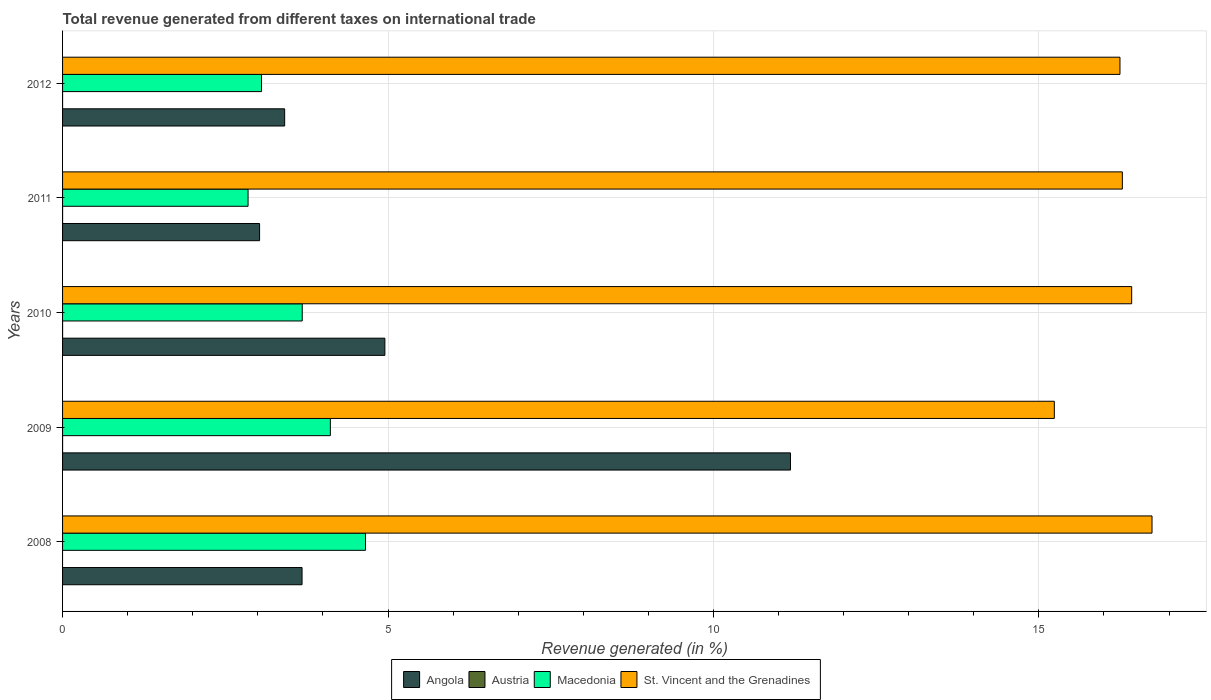How many different coloured bars are there?
Provide a succinct answer. 4. Are the number of bars per tick equal to the number of legend labels?
Keep it short and to the point. No. How many bars are there on the 3rd tick from the bottom?
Offer a terse response. 4. In how many cases, is the number of bars for a given year not equal to the number of legend labels?
Your answer should be compact. 1. What is the total revenue generated in Macedonia in 2012?
Keep it short and to the point. 3.06. Across all years, what is the maximum total revenue generated in Macedonia?
Offer a terse response. 4.65. Across all years, what is the minimum total revenue generated in Angola?
Your answer should be very brief. 3.03. What is the total total revenue generated in Angola in the graph?
Offer a terse response. 26.25. What is the difference between the total revenue generated in St. Vincent and the Grenadines in 2009 and that in 2010?
Your answer should be very brief. -1.19. What is the difference between the total revenue generated in Macedonia in 2010 and the total revenue generated in St. Vincent and the Grenadines in 2008?
Offer a very short reply. -13.06. What is the average total revenue generated in Macedonia per year?
Provide a succinct answer. 3.67. In the year 2010, what is the difference between the total revenue generated in Austria and total revenue generated in Angola?
Give a very brief answer. -4.95. In how many years, is the total revenue generated in Macedonia greater than 7 %?
Your answer should be compact. 0. What is the ratio of the total revenue generated in Macedonia in 2010 to that in 2011?
Offer a terse response. 1.29. Is the difference between the total revenue generated in Austria in 2009 and 2012 greater than the difference between the total revenue generated in Angola in 2009 and 2012?
Your answer should be very brief. No. What is the difference between the highest and the second highest total revenue generated in Macedonia?
Your answer should be compact. 0.54. What is the difference between the highest and the lowest total revenue generated in Angola?
Give a very brief answer. 8.16. In how many years, is the total revenue generated in Austria greater than the average total revenue generated in Austria taken over all years?
Offer a terse response. 4. Is the sum of the total revenue generated in St. Vincent and the Grenadines in 2010 and 2012 greater than the maximum total revenue generated in Angola across all years?
Keep it short and to the point. Yes. Are all the bars in the graph horizontal?
Provide a short and direct response. Yes. How many years are there in the graph?
Keep it short and to the point. 5. Does the graph contain grids?
Make the answer very short. Yes. What is the title of the graph?
Offer a very short reply. Total revenue generated from different taxes on international trade. Does "Lithuania" appear as one of the legend labels in the graph?
Keep it short and to the point. No. What is the label or title of the X-axis?
Ensure brevity in your answer.  Revenue generated (in %). What is the label or title of the Y-axis?
Keep it short and to the point. Years. What is the Revenue generated (in %) of Angola in 2008?
Provide a short and direct response. 3.68. What is the Revenue generated (in %) in Austria in 2008?
Offer a terse response. 0. What is the Revenue generated (in %) in Macedonia in 2008?
Provide a short and direct response. 4.65. What is the Revenue generated (in %) in St. Vincent and the Grenadines in 2008?
Offer a terse response. 16.74. What is the Revenue generated (in %) in Angola in 2009?
Ensure brevity in your answer.  11.18. What is the Revenue generated (in %) in Austria in 2009?
Your answer should be very brief. 6.92844166875675e-5. What is the Revenue generated (in %) of Macedonia in 2009?
Ensure brevity in your answer.  4.11. What is the Revenue generated (in %) in St. Vincent and the Grenadines in 2009?
Offer a very short reply. 15.24. What is the Revenue generated (in %) in Angola in 2010?
Provide a short and direct response. 4.95. What is the Revenue generated (in %) in Austria in 2010?
Give a very brief answer. 8.59505597100448e-5. What is the Revenue generated (in %) in Macedonia in 2010?
Offer a terse response. 3.68. What is the Revenue generated (in %) in St. Vincent and the Grenadines in 2010?
Offer a terse response. 16.43. What is the Revenue generated (in %) in Angola in 2011?
Keep it short and to the point. 3.03. What is the Revenue generated (in %) in Austria in 2011?
Keep it short and to the point. 7.3236472605577e-5. What is the Revenue generated (in %) of Macedonia in 2011?
Provide a short and direct response. 2.85. What is the Revenue generated (in %) of St. Vincent and the Grenadines in 2011?
Your response must be concise. 16.28. What is the Revenue generated (in %) of Angola in 2012?
Offer a terse response. 3.41. What is the Revenue generated (in %) of Austria in 2012?
Offer a terse response. 6.14359728333639e-5. What is the Revenue generated (in %) in Macedonia in 2012?
Provide a short and direct response. 3.06. What is the Revenue generated (in %) in St. Vincent and the Grenadines in 2012?
Offer a terse response. 16.25. Across all years, what is the maximum Revenue generated (in %) of Angola?
Offer a terse response. 11.18. Across all years, what is the maximum Revenue generated (in %) in Austria?
Your answer should be very brief. 8.59505597100448e-5. Across all years, what is the maximum Revenue generated (in %) of Macedonia?
Your answer should be very brief. 4.65. Across all years, what is the maximum Revenue generated (in %) of St. Vincent and the Grenadines?
Provide a short and direct response. 16.74. Across all years, what is the minimum Revenue generated (in %) of Angola?
Make the answer very short. 3.03. Across all years, what is the minimum Revenue generated (in %) in Macedonia?
Your response must be concise. 2.85. Across all years, what is the minimum Revenue generated (in %) in St. Vincent and the Grenadines?
Make the answer very short. 15.24. What is the total Revenue generated (in %) of Angola in the graph?
Keep it short and to the point. 26.25. What is the total Revenue generated (in %) of Macedonia in the graph?
Provide a short and direct response. 18.36. What is the total Revenue generated (in %) in St. Vincent and the Grenadines in the graph?
Your answer should be very brief. 80.93. What is the difference between the Revenue generated (in %) of Angola in 2008 and that in 2009?
Provide a succinct answer. -7.5. What is the difference between the Revenue generated (in %) of Macedonia in 2008 and that in 2009?
Keep it short and to the point. 0.54. What is the difference between the Revenue generated (in %) in St. Vincent and the Grenadines in 2008 and that in 2009?
Give a very brief answer. 1.5. What is the difference between the Revenue generated (in %) in Angola in 2008 and that in 2010?
Your answer should be very brief. -1.27. What is the difference between the Revenue generated (in %) of Macedonia in 2008 and that in 2010?
Offer a very short reply. 0.97. What is the difference between the Revenue generated (in %) of St. Vincent and the Grenadines in 2008 and that in 2010?
Your response must be concise. 0.31. What is the difference between the Revenue generated (in %) of Angola in 2008 and that in 2011?
Your answer should be compact. 0.65. What is the difference between the Revenue generated (in %) in Macedonia in 2008 and that in 2011?
Provide a succinct answer. 1.8. What is the difference between the Revenue generated (in %) in St. Vincent and the Grenadines in 2008 and that in 2011?
Offer a terse response. 0.46. What is the difference between the Revenue generated (in %) in Angola in 2008 and that in 2012?
Make the answer very short. 0.27. What is the difference between the Revenue generated (in %) of Macedonia in 2008 and that in 2012?
Ensure brevity in your answer.  1.6. What is the difference between the Revenue generated (in %) in St. Vincent and the Grenadines in 2008 and that in 2012?
Make the answer very short. 0.49. What is the difference between the Revenue generated (in %) of Angola in 2009 and that in 2010?
Give a very brief answer. 6.23. What is the difference between the Revenue generated (in %) in Austria in 2009 and that in 2010?
Give a very brief answer. -0. What is the difference between the Revenue generated (in %) in Macedonia in 2009 and that in 2010?
Offer a very short reply. 0.43. What is the difference between the Revenue generated (in %) in St. Vincent and the Grenadines in 2009 and that in 2010?
Your answer should be compact. -1.19. What is the difference between the Revenue generated (in %) of Angola in 2009 and that in 2011?
Give a very brief answer. 8.16. What is the difference between the Revenue generated (in %) of Austria in 2009 and that in 2011?
Keep it short and to the point. -0. What is the difference between the Revenue generated (in %) in Macedonia in 2009 and that in 2011?
Provide a short and direct response. 1.26. What is the difference between the Revenue generated (in %) in St. Vincent and the Grenadines in 2009 and that in 2011?
Your answer should be compact. -1.04. What is the difference between the Revenue generated (in %) of Angola in 2009 and that in 2012?
Keep it short and to the point. 7.77. What is the difference between the Revenue generated (in %) of Macedonia in 2009 and that in 2012?
Ensure brevity in your answer.  1.06. What is the difference between the Revenue generated (in %) of St. Vincent and the Grenadines in 2009 and that in 2012?
Provide a succinct answer. -1.01. What is the difference between the Revenue generated (in %) in Angola in 2010 and that in 2011?
Provide a succinct answer. 1.93. What is the difference between the Revenue generated (in %) in Macedonia in 2010 and that in 2011?
Your answer should be compact. 0.83. What is the difference between the Revenue generated (in %) in St. Vincent and the Grenadines in 2010 and that in 2011?
Offer a very short reply. 0.14. What is the difference between the Revenue generated (in %) in Angola in 2010 and that in 2012?
Your response must be concise. 1.54. What is the difference between the Revenue generated (in %) of Macedonia in 2010 and that in 2012?
Your answer should be very brief. 0.63. What is the difference between the Revenue generated (in %) of St. Vincent and the Grenadines in 2010 and that in 2012?
Offer a very short reply. 0.18. What is the difference between the Revenue generated (in %) of Angola in 2011 and that in 2012?
Make the answer very short. -0.39. What is the difference between the Revenue generated (in %) in Austria in 2011 and that in 2012?
Your answer should be compact. 0. What is the difference between the Revenue generated (in %) in Macedonia in 2011 and that in 2012?
Provide a short and direct response. -0.21. What is the difference between the Revenue generated (in %) in St. Vincent and the Grenadines in 2011 and that in 2012?
Provide a short and direct response. 0.04. What is the difference between the Revenue generated (in %) in Angola in 2008 and the Revenue generated (in %) in Austria in 2009?
Your answer should be very brief. 3.68. What is the difference between the Revenue generated (in %) in Angola in 2008 and the Revenue generated (in %) in Macedonia in 2009?
Your response must be concise. -0.43. What is the difference between the Revenue generated (in %) of Angola in 2008 and the Revenue generated (in %) of St. Vincent and the Grenadines in 2009?
Keep it short and to the point. -11.56. What is the difference between the Revenue generated (in %) in Macedonia in 2008 and the Revenue generated (in %) in St. Vincent and the Grenadines in 2009?
Your answer should be very brief. -10.58. What is the difference between the Revenue generated (in %) in Angola in 2008 and the Revenue generated (in %) in Austria in 2010?
Your answer should be very brief. 3.68. What is the difference between the Revenue generated (in %) in Angola in 2008 and the Revenue generated (in %) in Macedonia in 2010?
Keep it short and to the point. -0. What is the difference between the Revenue generated (in %) in Angola in 2008 and the Revenue generated (in %) in St. Vincent and the Grenadines in 2010?
Offer a very short reply. -12.75. What is the difference between the Revenue generated (in %) of Macedonia in 2008 and the Revenue generated (in %) of St. Vincent and the Grenadines in 2010?
Give a very brief answer. -11.77. What is the difference between the Revenue generated (in %) in Angola in 2008 and the Revenue generated (in %) in Austria in 2011?
Ensure brevity in your answer.  3.68. What is the difference between the Revenue generated (in %) of Angola in 2008 and the Revenue generated (in %) of Macedonia in 2011?
Give a very brief answer. 0.83. What is the difference between the Revenue generated (in %) of Angola in 2008 and the Revenue generated (in %) of St. Vincent and the Grenadines in 2011?
Offer a terse response. -12.6. What is the difference between the Revenue generated (in %) of Macedonia in 2008 and the Revenue generated (in %) of St. Vincent and the Grenadines in 2011?
Ensure brevity in your answer.  -11.63. What is the difference between the Revenue generated (in %) of Angola in 2008 and the Revenue generated (in %) of Austria in 2012?
Offer a terse response. 3.68. What is the difference between the Revenue generated (in %) of Angola in 2008 and the Revenue generated (in %) of Macedonia in 2012?
Your answer should be compact. 0.62. What is the difference between the Revenue generated (in %) in Angola in 2008 and the Revenue generated (in %) in St. Vincent and the Grenadines in 2012?
Give a very brief answer. -12.57. What is the difference between the Revenue generated (in %) in Macedonia in 2008 and the Revenue generated (in %) in St. Vincent and the Grenadines in 2012?
Provide a short and direct response. -11.59. What is the difference between the Revenue generated (in %) in Angola in 2009 and the Revenue generated (in %) in Austria in 2010?
Make the answer very short. 11.18. What is the difference between the Revenue generated (in %) of Angola in 2009 and the Revenue generated (in %) of Macedonia in 2010?
Your answer should be very brief. 7.5. What is the difference between the Revenue generated (in %) in Angola in 2009 and the Revenue generated (in %) in St. Vincent and the Grenadines in 2010?
Your answer should be very brief. -5.24. What is the difference between the Revenue generated (in %) of Austria in 2009 and the Revenue generated (in %) of Macedonia in 2010?
Keep it short and to the point. -3.68. What is the difference between the Revenue generated (in %) of Austria in 2009 and the Revenue generated (in %) of St. Vincent and the Grenadines in 2010?
Your answer should be compact. -16.43. What is the difference between the Revenue generated (in %) in Macedonia in 2009 and the Revenue generated (in %) in St. Vincent and the Grenadines in 2010?
Keep it short and to the point. -12.31. What is the difference between the Revenue generated (in %) of Angola in 2009 and the Revenue generated (in %) of Austria in 2011?
Offer a terse response. 11.18. What is the difference between the Revenue generated (in %) of Angola in 2009 and the Revenue generated (in %) of Macedonia in 2011?
Your answer should be compact. 8.33. What is the difference between the Revenue generated (in %) of Angola in 2009 and the Revenue generated (in %) of St. Vincent and the Grenadines in 2011?
Your answer should be very brief. -5.1. What is the difference between the Revenue generated (in %) in Austria in 2009 and the Revenue generated (in %) in Macedonia in 2011?
Keep it short and to the point. -2.85. What is the difference between the Revenue generated (in %) of Austria in 2009 and the Revenue generated (in %) of St. Vincent and the Grenadines in 2011?
Provide a short and direct response. -16.28. What is the difference between the Revenue generated (in %) of Macedonia in 2009 and the Revenue generated (in %) of St. Vincent and the Grenadines in 2011?
Make the answer very short. -12.17. What is the difference between the Revenue generated (in %) of Angola in 2009 and the Revenue generated (in %) of Austria in 2012?
Your response must be concise. 11.18. What is the difference between the Revenue generated (in %) of Angola in 2009 and the Revenue generated (in %) of Macedonia in 2012?
Make the answer very short. 8.13. What is the difference between the Revenue generated (in %) in Angola in 2009 and the Revenue generated (in %) in St. Vincent and the Grenadines in 2012?
Offer a very short reply. -5.06. What is the difference between the Revenue generated (in %) in Austria in 2009 and the Revenue generated (in %) in Macedonia in 2012?
Keep it short and to the point. -3.06. What is the difference between the Revenue generated (in %) in Austria in 2009 and the Revenue generated (in %) in St. Vincent and the Grenadines in 2012?
Give a very brief answer. -16.25. What is the difference between the Revenue generated (in %) in Macedonia in 2009 and the Revenue generated (in %) in St. Vincent and the Grenadines in 2012?
Your answer should be very brief. -12.13. What is the difference between the Revenue generated (in %) of Angola in 2010 and the Revenue generated (in %) of Austria in 2011?
Ensure brevity in your answer.  4.95. What is the difference between the Revenue generated (in %) of Angola in 2010 and the Revenue generated (in %) of Macedonia in 2011?
Provide a succinct answer. 2.1. What is the difference between the Revenue generated (in %) of Angola in 2010 and the Revenue generated (in %) of St. Vincent and the Grenadines in 2011?
Give a very brief answer. -11.33. What is the difference between the Revenue generated (in %) of Austria in 2010 and the Revenue generated (in %) of Macedonia in 2011?
Your answer should be compact. -2.85. What is the difference between the Revenue generated (in %) in Austria in 2010 and the Revenue generated (in %) in St. Vincent and the Grenadines in 2011?
Give a very brief answer. -16.28. What is the difference between the Revenue generated (in %) in Macedonia in 2010 and the Revenue generated (in %) in St. Vincent and the Grenadines in 2011?
Make the answer very short. -12.6. What is the difference between the Revenue generated (in %) in Angola in 2010 and the Revenue generated (in %) in Austria in 2012?
Keep it short and to the point. 4.95. What is the difference between the Revenue generated (in %) of Angola in 2010 and the Revenue generated (in %) of Macedonia in 2012?
Give a very brief answer. 1.9. What is the difference between the Revenue generated (in %) in Angola in 2010 and the Revenue generated (in %) in St. Vincent and the Grenadines in 2012?
Provide a succinct answer. -11.29. What is the difference between the Revenue generated (in %) in Austria in 2010 and the Revenue generated (in %) in Macedonia in 2012?
Offer a terse response. -3.06. What is the difference between the Revenue generated (in %) of Austria in 2010 and the Revenue generated (in %) of St. Vincent and the Grenadines in 2012?
Offer a terse response. -16.25. What is the difference between the Revenue generated (in %) in Macedonia in 2010 and the Revenue generated (in %) in St. Vincent and the Grenadines in 2012?
Make the answer very short. -12.56. What is the difference between the Revenue generated (in %) in Angola in 2011 and the Revenue generated (in %) in Austria in 2012?
Provide a succinct answer. 3.03. What is the difference between the Revenue generated (in %) of Angola in 2011 and the Revenue generated (in %) of Macedonia in 2012?
Make the answer very short. -0.03. What is the difference between the Revenue generated (in %) in Angola in 2011 and the Revenue generated (in %) in St. Vincent and the Grenadines in 2012?
Provide a short and direct response. -13.22. What is the difference between the Revenue generated (in %) in Austria in 2011 and the Revenue generated (in %) in Macedonia in 2012?
Your answer should be compact. -3.06. What is the difference between the Revenue generated (in %) of Austria in 2011 and the Revenue generated (in %) of St. Vincent and the Grenadines in 2012?
Your answer should be compact. -16.25. What is the difference between the Revenue generated (in %) in Macedonia in 2011 and the Revenue generated (in %) in St. Vincent and the Grenadines in 2012?
Offer a terse response. -13.4. What is the average Revenue generated (in %) of Angola per year?
Give a very brief answer. 5.25. What is the average Revenue generated (in %) in Macedonia per year?
Keep it short and to the point. 3.67. What is the average Revenue generated (in %) of St. Vincent and the Grenadines per year?
Provide a short and direct response. 16.19. In the year 2008, what is the difference between the Revenue generated (in %) of Angola and Revenue generated (in %) of Macedonia?
Your response must be concise. -0.97. In the year 2008, what is the difference between the Revenue generated (in %) of Angola and Revenue generated (in %) of St. Vincent and the Grenadines?
Make the answer very short. -13.06. In the year 2008, what is the difference between the Revenue generated (in %) in Macedonia and Revenue generated (in %) in St. Vincent and the Grenadines?
Your answer should be compact. -12.08. In the year 2009, what is the difference between the Revenue generated (in %) in Angola and Revenue generated (in %) in Austria?
Give a very brief answer. 11.18. In the year 2009, what is the difference between the Revenue generated (in %) in Angola and Revenue generated (in %) in Macedonia?
Keep it short and to the point. 7.07. In the year 2009, what is the difference between the Revenue generated (in %) of Angola and Revenue generated (in %) of St. Vincent and the Grenadines?
Give a very brief answer. -4.05. In the year 2009, what is the difference between the Revenue generated (in %) of Austria and Revenue generated (in %) of Macedonia?
Your answer should be compact. -4.11. In the year 2009, what is the difference between the Revenue generated (in %) in Austria and Revenue generated (in %) in St. Vincent and the Grenadines?
Make the answer very short. -15.24. In the year 2009, what is the difference between the Revenue generated (in %) in Macedonia and Revenue generated (in %) in St. Vincent and the Grenadines?
Provide a short and direct response. -11.12. In the year 2010, what is the difference between the Revenue generated (in %) of Angola and Revenue generated (in %) of Austria?
Keep it short and to the point. 4.95. In the year 2010, what is the difference between the Revenue generated (in %) in Angola and Revenue generated (in %) in Macedonia?
Your response must be concise. 1.27. In the year 2010, what is the difference between the Revenue generated (in %) in Angola and Revenue generated (in %) in St. Vincent and the Grenadines?
Provide a succinct answer. -11.47. In the year 2010, what is the difference between the Revenue generated (in %) of Austria and Revenue generated (in %) of Macedonia?
Provide a short and direct response. -3.68. In the year 2010, what is the difference between the Revenue generated (in %) of Austria and Revenue generated (in %) of St. Vincent and the Grenadines?
Your response must be concise. -16.43. In the year 2010, what is the difference between the Revenue generated (in %) of Macedonia and Revenue generated (in %) of St. Vincent and the Grenadines?
Provide a short and direct response. -12.74. In the year 2011, what is the difference between the Revenue generated (in %) of Angola and Revenue generated (in %) of Austria?
Make the answer very short. 3.03. In the year 2011, what is the difference between the Revenue generated (in %) of Angola and Revenue generated (in %) of Macedonia?
Your answer should be very brief. 0.18. In the year 2011, what is the difference between the Revenue generated (in %) of Angola and Revenue generated (in %) of St. Vincent and the Grenadines?
Ensure brevity in your answer.  -13.26. In the year 2011, what is the difference between the Revenue generated (in %) of Austria and Revenue generated (in %) of Macedonia?
Your answer should be compact. -2.85. In the year 2011, what is the difference between the Revenue generated (in %) of Austria and Revenue generated (in %) of St. Vincent and the Grenadines?
Provide a short and direct response. -16.28. In the year 2011, what is the difference between the Revenue generated (in %) in Macedonia and Revenue generated (in %) in St. Vincent and the Grenadines?
Ensure brevity in your answer.  -13.43. In the year 2012, what is the difference between the Revenue generated (in %) in Angola and Revenue generated (in %) in Austria?
Provide a short and direct response. 3.41. In the year 2012, what is the difference between the Revenue generated (in %) of Angola and Revenue generated (in %) of Macedonia?
Make the answer very short. 0.36. In the year 2012, what is the difference between the Revenue generated (in %) in Angola and Revenue generated (in %) in St. Vincent and the Grenadines?
Your answer should be very brief. -12.83. In the year 2012, what is the difference between the Revenue generated (in %) of Austria and Revenue generated (in %) of Macedonia?
Provide a succinct answer. -3.06. In the year 2012, what is the difference between the Revenue generated (in %) of Austria and Revenue generated (in %) of St. Vincent and the Grenadines?
Your response must be concise. -16.25. In the year 2012, what is the difference between the Revenue generated (in %) of Macedonia and Revenue generated (in %) of St. Vincent and the Grenadines?
Your answer should be compact. -13.19. What is the ratio of the Revenue generated (in %) of Angola in 2008 to that in 2009?
Offer a terse response. 0.33. What is the ratio of the Revenue generated (in %) in Macedonia in 2008 to that in 2009?
Make the answer very short. 1.13. What is the ratio of the Revenue generated (in %) of St. Vincent and the Grenadines in 2008 to that in 2009?
Your answer should be very brief. 1.1. What is the ratio of the Revenue generated (in %) of Angola in 2008 to that in 2010?
Offer a very short reply. 0.74. What is the ratio of the Revenue generated (in %) of Macedonia in 2008 to that in 2010?
Make the answer very short. 1.26. What is the ratio of the Revenue generated (in %) of Angola in 2008 to that in 2011?
Offer a terse response. 1.22. What is the ratio of the Revenue generated (in %) in Macedonia in 2008 to that in 2011?
Keep it short and to the point. 1.63. What is the ratio of the Revenue generated (in %) in St. Vincent and the Grenadines in 2008 to that in 2011?
Ensure brevity in your answer.  1.03. What is the ratio of the Revenue generated (in %) in Angola in 2008 to that in 2012?
Offer a terse response. 1.08. What is the ratio of the Revenue generated (in %) in Macedonia in 2008 to that in 2012?
Your answer should be very brief. 1.52. What is the ratio of the Revenue generated (in %) of St. Vincent and the Grenadines in 2008 to that in 2012?
Make the answer very short. 1.03. What is the ratio of the Revenue generated (in %) of Angola in 2009 to that in 2010?
Offer a terse response. 2.26. What is the ratio of the Revenue generated (in %) of Austria in 2009 to that in 2010?
Provide a short and direct response. 0.81. What is the ratio of the Revenue generated (in %) of Macedonia in 2009 to that in 2010?
Offer a very short reply. 1.12. What is the ratio of the Revenue generated (in %) of St. Vincent and the Grenadines in 2009 to that in 2010?
Keep it short and to the point. 0.93. What is the ratio of the Revenue generated (in %) of Angola in 2009 to that in 2011?
Ensure brevity in your answer.  3.69. What is the ratio of the Revenue generated (in %) of Austria in 2009 to that in 2011?
Offer a terse response. 0.95. What is the ratio of the Revenue generated (in %) in Macedonia in 2009 to that in 2011?
Your response must be concise. 1.44. What is the ratio of the Revenue generated (in %) of St. Vincent and the Grenadines in 2009 to that in 2011?
Make the answer very short. 0.94. What is the ratio of the Revenue generated (in %) in Angola in 2009 to that in 2012?
Ensure brevity in your answer.  3.28. What is the ratio of the Revenue generated (in %) in Austria in 2009 to that in 2012?
Offer a terse response. 1.13. What is the ratio of the Revenue generated (in %) in Macedonia in 2009 to that in 2012?
Keep it short and to the point. 1.35. What is the ratio of the Revenue generated (in %) of St. Vincent and the Grenadines in 2009 to that in 2012?
Make the answer very short. 0.94. What is the ratio of the Revenue generated (in %) in Angola in 2010 to that in 2011?
Your response must be concise. 1.64. What is the ratio of the Revenue generated (in %) of Austria in 2010 to that in 2011?
Provide a short and direct response. 1.17. What is the ratio of the Revenue generated (in %) in Macedonia in 2010 to that in 2011?
Offer a terse response. 1.29. What is the ratio of the Revenue generated (in %) of St. Vincent and the Grenadines in 2010 to that in 2011?
Ensure brevity in your answer.  1.01. What is the ratio of the Revenue generated (in %) in Angola in 2010 to that in 2012?
Your response must be concise. 1.45. What is the ratio of the Revenue generated (in %) of Austria in 2010 to that in 2012?
Provide a short and direct response. 1.4. What is the ratio of the Revenue generated (in %) in Macedonia in 2010 to that in 2012?
Your response must be concise. 1.2. What is the ratio of the Revenue generated (in %) in St. Vincent and the Grenadines in 2010 to that in 2012?
Keep it short and to the point. 1.01. What is the ratio of the Revenue generated (in %) of Angola in 2011 to that in 2012?
Your response must be concise. 0.89. What is the ratio of the Revenue generated (in %) in Austria in 2011 to that in 2012?
Your response must be concise. 1.19. What is the ratio of the Revenue generated (in %) in Macedonia in 2011 to that in 2012?
Provide a short and direct response. 0.93. What is the ratio of the Revenue generated (in %) in St. Vincent and the Grenadines in 2011 to that in 2012?
Offer a terse response. 1. What is the difference between the highest and the second highest Revenue generated (in %) of Angola?
Provide a short and direct response. 6.23. What is the difference between the highest and the second highest Revenue generated (in %) of Austria?
Your answer should be compact. 0. What is the difference between the highest and the second highest Revenue generated (in %) in Macedonia?
Provide a short and direct response. 0.54. What is the difference between the highest and the second highest Revenue generated (in %) in St. Vincent and the Grenadines?
Provide a short and direct response. 0.31. What is the difference between the highest and the lowest Revenue generated (in %) in Angola?
Ensure brevity in your answer.  8.16. What is the difference between the highest and the lowest Revenue generated (in %) of Macedonia?
Your answer should be compact. 1.8. What is the difference between the highest and the lowest Revenue generated (in %) in St. Vincent and the Grenadines?
Your response must be concise. 1.5. 